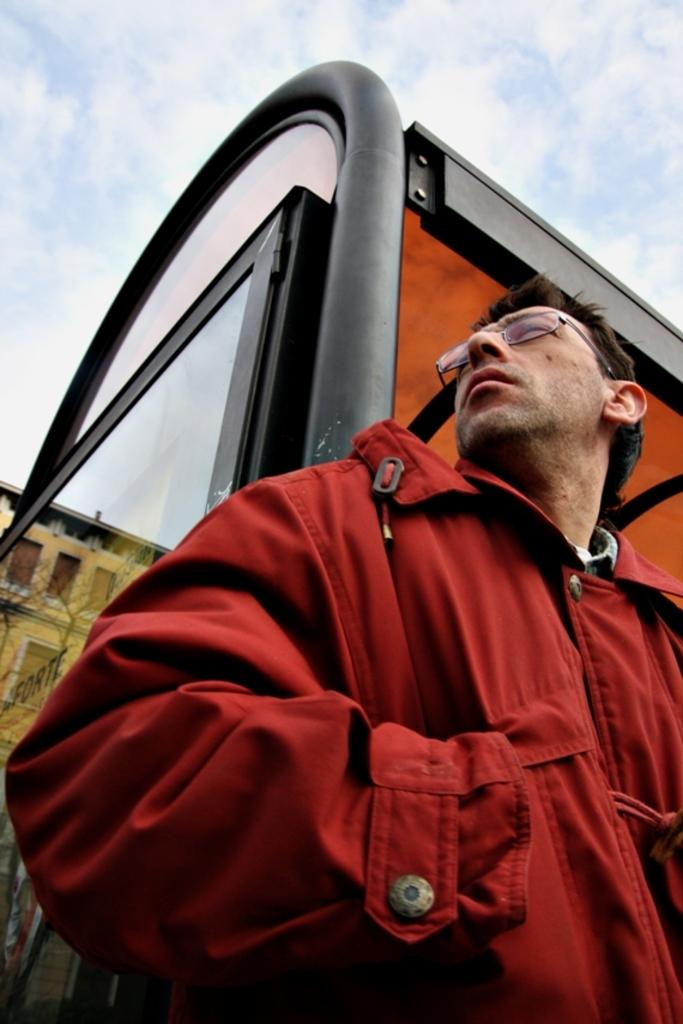What is the main subject in the foreground of the image? There is a person in the foreground of the image. What is the location of the person in the image? The person is on a roof, which appears to be in the foreground area. What can be seen in the background of the image? There is a building and the sky visible in the background of the image. What type of yak can be seen in the image? There is no yak present in the image. How many legs does the person in the image have? The person in the image has two legs, as is typical for humans. 